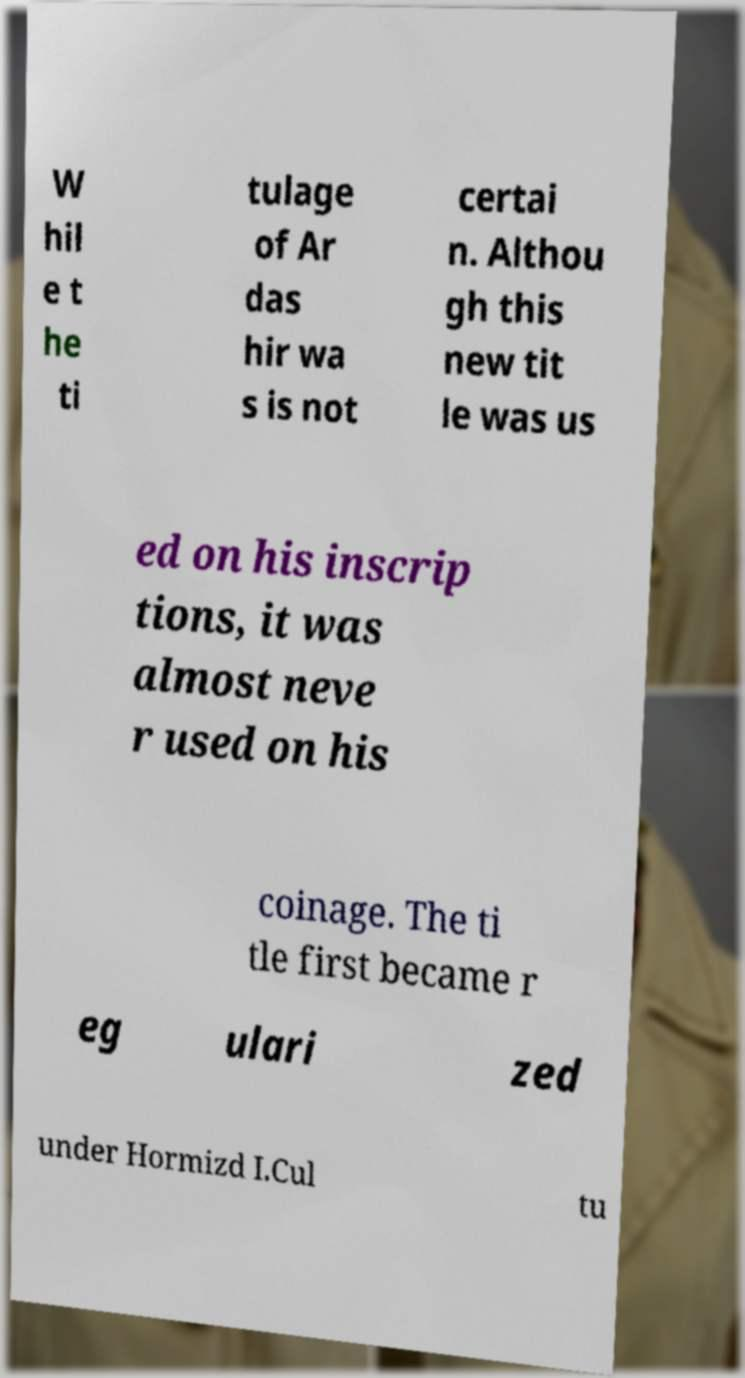Could you extract and type out the text from this image? W hil e t he ti tulage of Ar das hir wa s is not certai n. Althou gh this new tit le was us ed on his inscrip tions, it was almost neve r used on his coinage. The ti tle first became r eg ulari zed under Hormizd I.Cul tu 